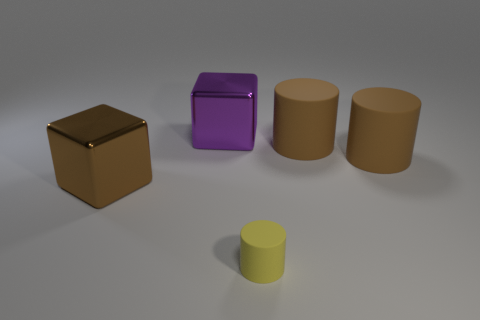Add 2 big metallic objects. How many objects exist? 7 Subtract all blocks. How many objects are left? 3 Add 3 large purple metal objects. How many large purple metal objects are left? 4 Add 5 small red metal cylinders. How many small red metal cylinders exist? 5 Subtract 0 green balls. How many objects are left? 5 Subtract all cylinders. Subtract all large metal blocks. How many objects are left? 0 